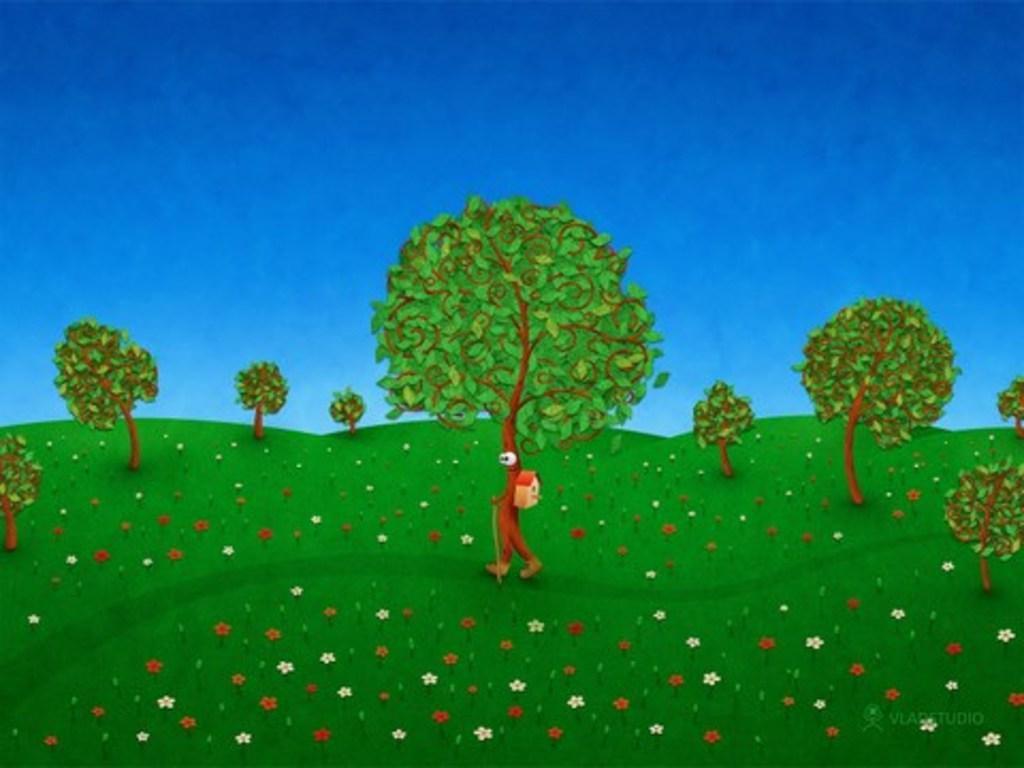Please provide a concise description of this image. This is an edited image. In this image we can see a group of trees, some flowers, grass and the sky which looks cloudy. In the center of the image we can see a tree walking holding a stick. 